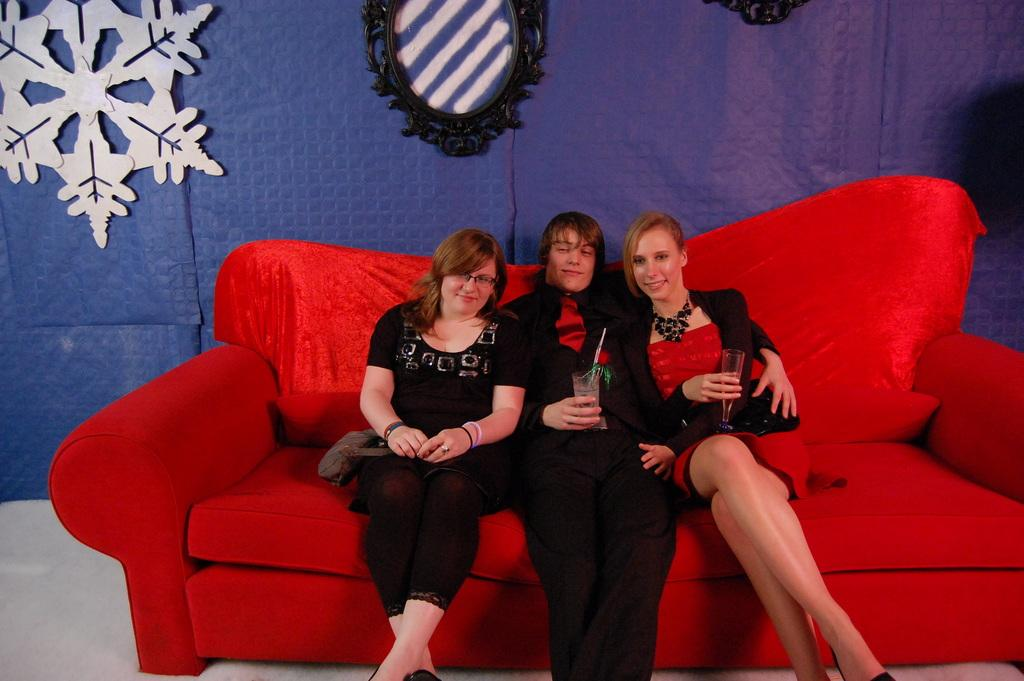How many people are in the image? There are two girls and a man in the image, making a total of three people. What are the girls doing in the image? The girls are sitting on either side of a man. What is the man holding in the image? The man is holding a glass. What type of furniture is present in the image? There is a red color sofa in the image. What other object can be seen in the image? There is a mirror in the image. Can you see the girls skating in the image? No, there is no skating activity depicted in the image. Is the man biting into an apple in the image? No, the man is holding a glass, not an apple, in the image. 